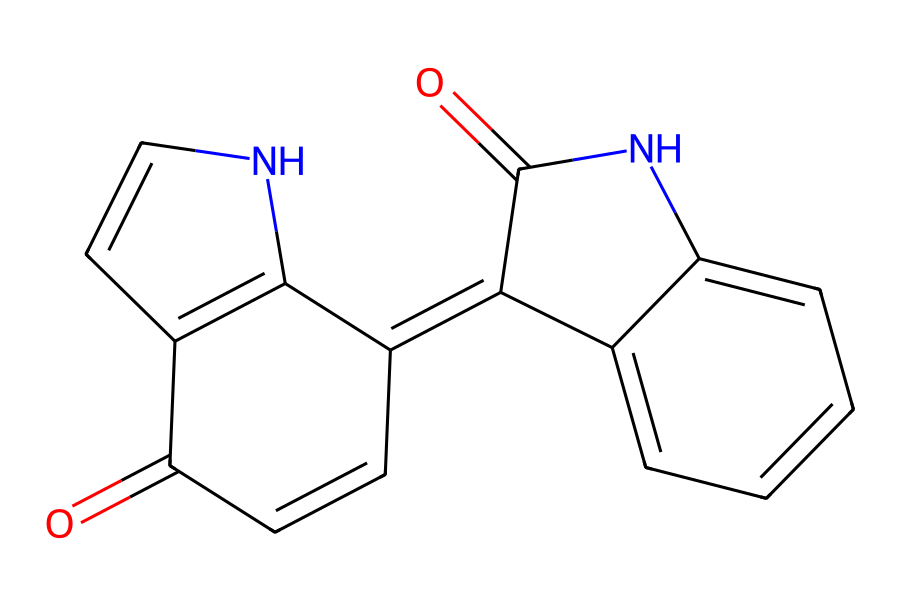What is the molecular formula of indigo dye? To determine the molecular formula from the SMILES representation, we can count the different types of atoms present. In the structure, we find carbon (C), hydrogen (H), nitrogen (N), and oxygen (O). By counting: there are 16 carbons, 10 hydrogens, 2 nitrogens, and 2 oxygens, leading to the formula C16H10N2O2.
Answer: C16H10N2O2 How many rings are present in the indigo structure? Looking at the structure, we can see that there are several interconnected cyclic structures. Counting the distinct rings, it is identified that there are three separate rings in the indigo molecule.
Answer: 3 What are the functional groups present in indigo dye? By analyzing the SMILES representation, we identify the presence of carbonyl (C=O) and amine (N-H) groups within the structure. These functional groups are responsible for its chemical properties and reactivity.
Answer: carbonyl and amine What type of dye is indigo classified as? Indigo is classified as a vat dye, which is a type of dye that is insoluble in water yet can be converted into a soluble form for dyeing fabrics. This classification is based on its characteristics in the dyeing process.
Answer: vat dye What is the significance of nitrogen atoms in indigo? The presence of nitrogen atoms is crucial for the dye's properties, as they contribute to the conjugated system in the chemical structure, influencing the color and stability of the dye during the dyeing process.
Answer: contributes to color How does the planar structure of indigo dye affect its properties? The planar structure of the indigo dye allows for effective pi-stacking interactions, enhancing the dye's stability and absorption properties, which are essential for its application in textiles.
Answer: enhances stability Which chemical process is used for dyeing with indigo? The dyeing process with indigo involves a reduction step where the indigo is reduced to a soluble form, followed by oxidation to revert it back to the insoluble form on the fabric, which is essential for its application.
Answer: reduction and oxidation 